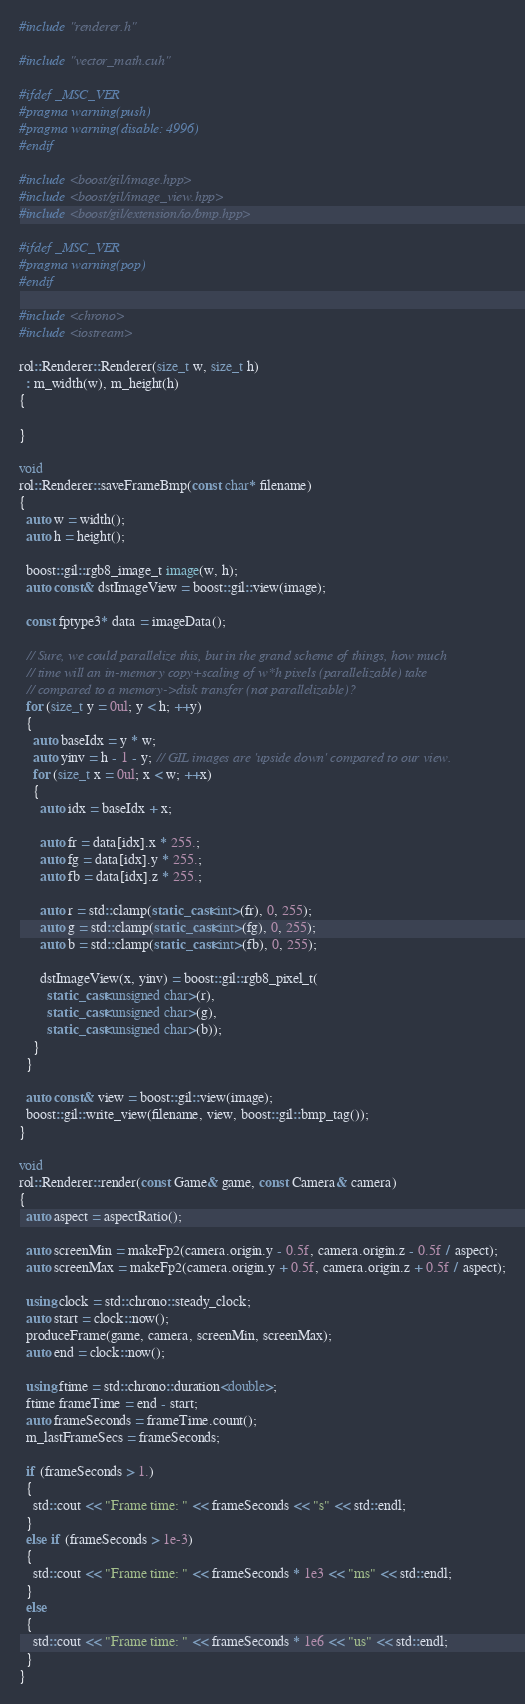<code> <loc_0><loc_0><loc_500><loc_500><_C++_>#include "renderer.h"

#include "vector_math.cuh"

#ifdef _MSC_VER
#pragma warning(push)
#pragma warning(disable: 4996)
#endif

#include <boost/gil/image.hpp>
#include <boost/gil/image_view.hpp>
#include <boost/gil/extension/io/bmp.hpp>

#ifdef _MSC_VER
#pragma warning(pop)
#endif

#include <chrono>
#include <iostream>

rol::Renderer::Renderer(size_t w, size_t h)
  : m_width(w), m_height(h)
{

}

void
rol::Renderer::saveFrameBmp(const char* filename)
{
  auto w = width();
  auto h = height();

  boost::gil::rgb8_image_t image(w, h);
  auto const& dstImageView = boost::gil::view(image);

  const fptype3* data = imageData();

  // Sure, we could parallelize this, but in the grand scheme of things, how much
  // time will an in-memory copy+scaling of w*h pixels (parallelizable) take
  // compared to a memory->disk transfer (not parallelizable)?
  for (size_t y = 0ul; y < h; ++y)
  {
    auto baseIdx = y * w;
    auto yinv = h - 1 - y; // GIL images are 'upside down' compared to our view.
    for (size_t x = 0ul; x < w; ++x)
    {
      auto idx = baseIdx + x;
      
      auto fr = data[idx].x * 255.;
      auto fg = data[idx].y * 255.;
      auto fb = data[idx].z * 255.;

      auto r = std::clamp(static_cast<int>(fr), 0, 255);
      auto g = std::clamp(static_cast<int>(fg), 0, 255);
      auto b = std::clamp(static_cast<int>(fb), 0, 255);

      dstImageView(x, yinv) = boost::gil::rgb8_pixel_t(
        static_cast<unsigned char>(r),
        static_cast<unsigned char>(g),
        static_cast<unsigned char>(b));
    }
  }

  auto const& view = boost::gil::view(image);
  boost::gil::write_view(filename, view, boost::gil::bmp_tag());
}

void
rol::Renderer::render(const Game& game, const Camera& camera)
{
  auto aspect = aspectRatio();

  auto screenMin = makeFp2(camera.origin.y - 0.5f, camera.origin.z - 0.5f / aspect);
  auto screenMax = makeFp2(camera.origin.y + 0.5f, camera.origin.z + 0.5f / aspect);

  using clock = std::chrono::steady_clock;
  auto start = clock::now();
  produceFrame(game, camera, screenMin, screenMax);
  auto end = clock::now();

  using ftime = std::chrono::duration<double>;
  ftime frameTime = end - start;
  auto frameSeconds = frameTime.count();
  m_lastFrameSecs = frameSeconds;

  if (frameSeconds > 1.)
  {
    std::cout << "Frame time: " << frameSeconds << "s" << std::endl;
  }
  else if (frameSeconds > 1e-3)
  {
    std::cout << "Frame time: " << frameSeconds * 1e3 << "ms" << std::endl;
  }
  else
  {
    std::cout << "Frame time: " << frameSeconds * 1e6 << "us" << std::endl;
  }
}
</code> 